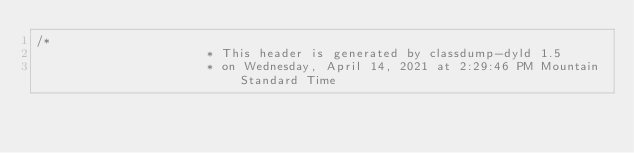<code> <loc_0><loc_0><loc_500><loc_500><_C_>/*
                       * This header is generated by classdump-dyld 1.5
                       * on Wednesday, April 14, 2021 at 2:29:46 PM Mountain Standard Time</code> 